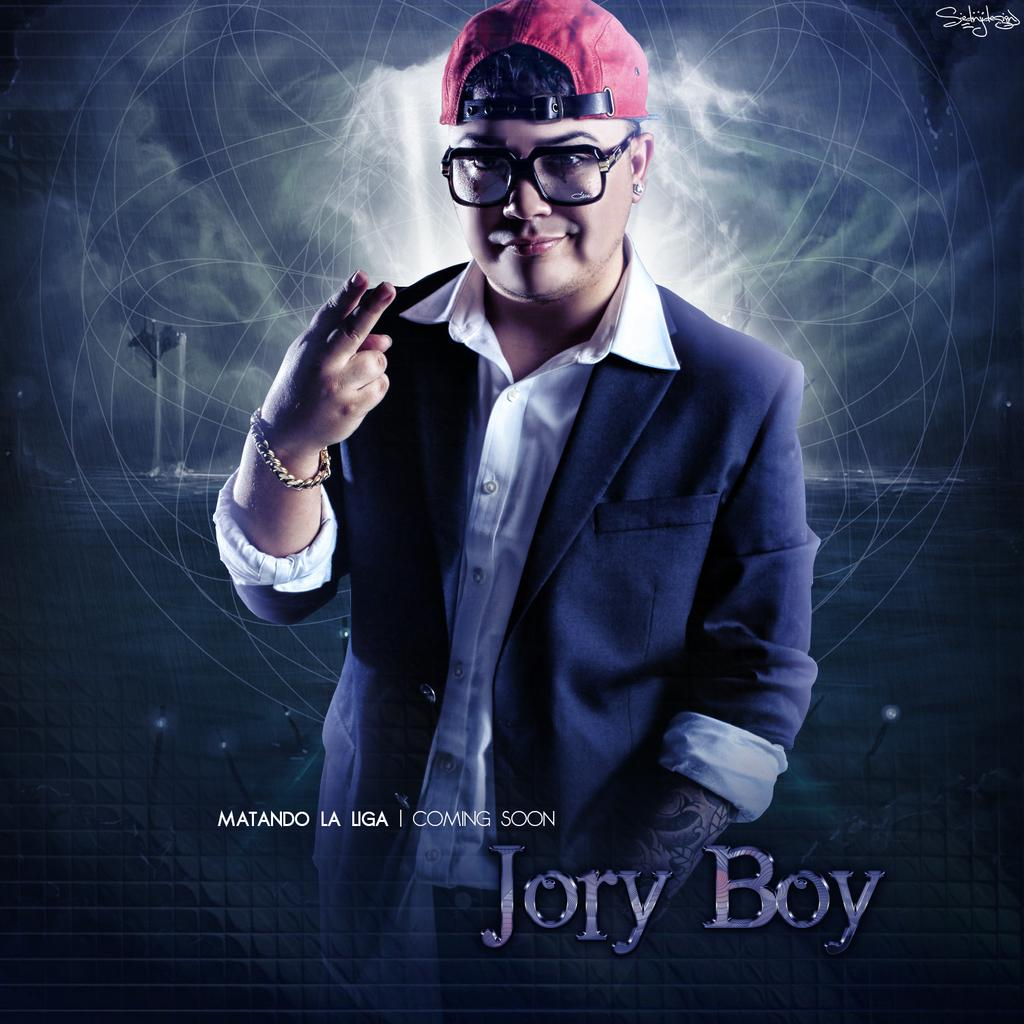What is located in the foreground of the image? There is a person in the foreground of the image, along with some text. What can be seen in the background of the image? There is a wall in the background of the image, and there are boats in the water. What time of day was the image taken? The image was taken during nighttime. What type of industry can be seen in the image? There is no industry present in the image; it features a person, text, a wall, boats, and water. Are there any fairies visible in the image? There are no fairies present in the image. 